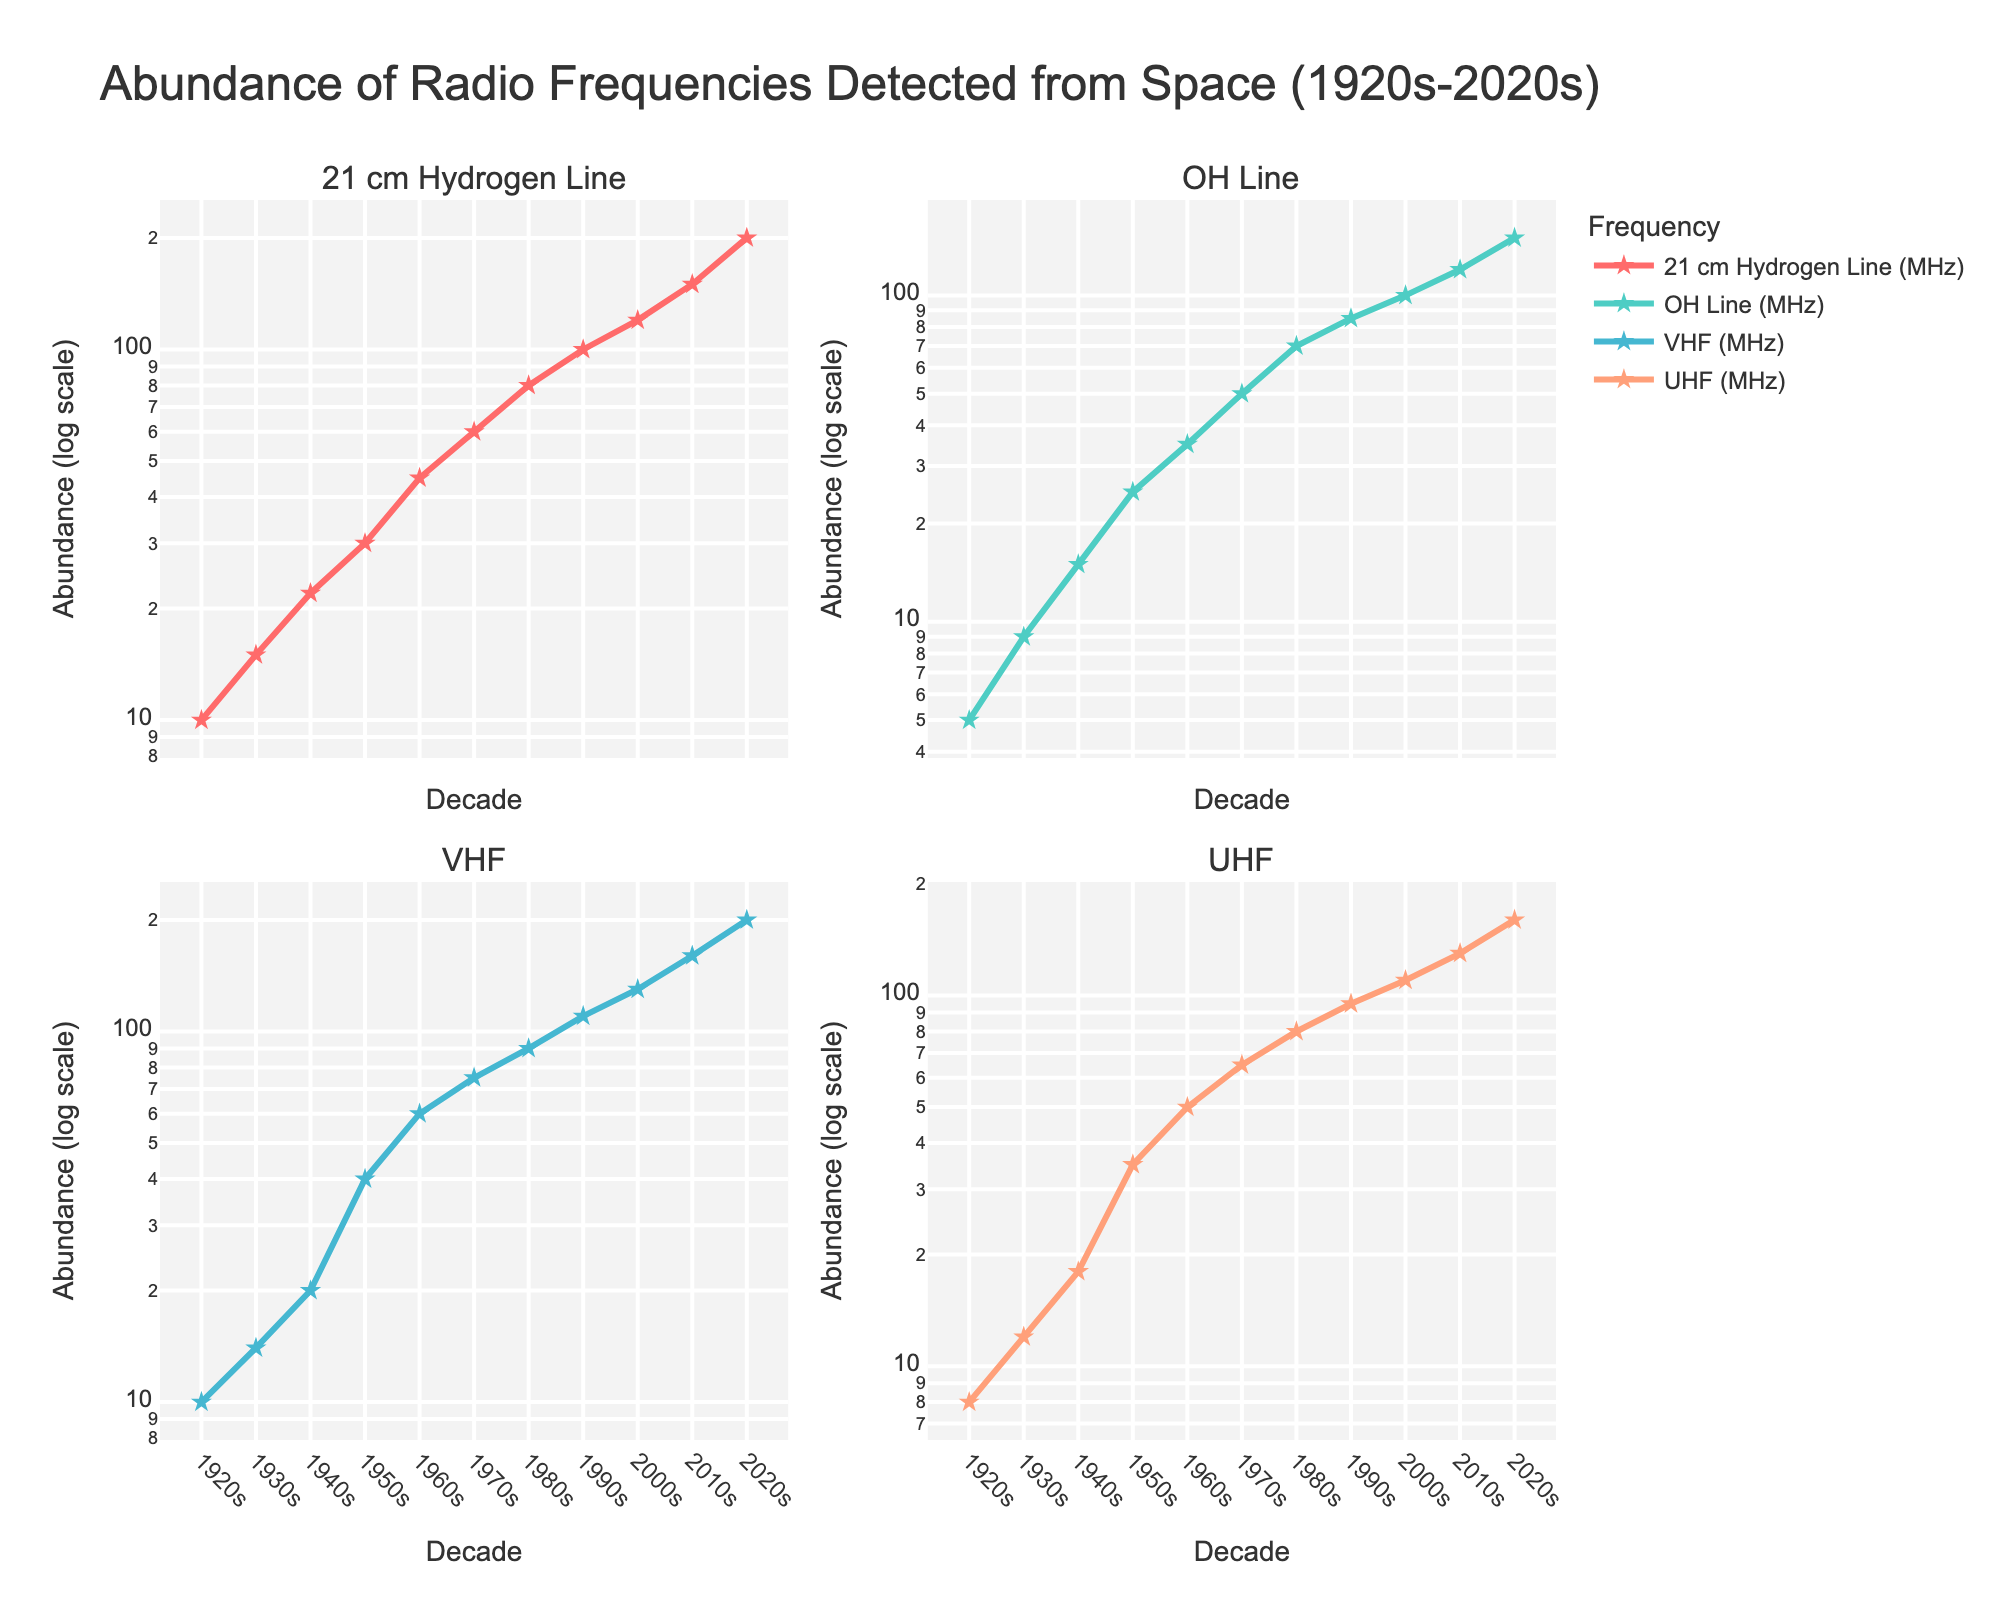What is the title of the plot? The title is found at the top of the plot and provides an overview of the data depicted. In this case, it reads: "Abundance of Radio Frequencies Detected from Space (1920s-2020s)"
Answer: Abundance of Radio Frequencies Detected from Space (1920s-2020s) What are the four frequencies analyzed in the subplots? By looking at the subplot titles, we can identify the four frequencies. They are "21 cm Hydrogen Line," "OH Line," "VHF," and "UHF."
Answer: 21 cm Hydrogen Line, OH Line, VHF, UHF Which decade shows the highest abundance for the OH Line frequency? We identify the OH Line subplot and observe that the highest value is in the 2020s.
Answer: 2020s How did the abundance of the 21 cm Hydrogen Line change from the 1930s to the 1940s? By comparing the data points in the 21 cm Hydrogen Line subplot for the 1930s and 1940s, we see an increase from 15 to 22.
Answer: Increased from 15 to 22 Compare the increase in abundance of VHF from the 1950s to the 1960s with that of UHF for the same period. Which increased more? For VHF, the abundance increases from 40 to 60 (20 units). For UHF, it increases from 35 to 50 (15 units). So, VHF increased more.
Answer: VHF What can you infer about the trend in the abundance of detected frequencies over the century? By examining all subplots, we notice an overall upward trend across all frequencies, indicating an increase in detected frequencies over the decades.
Answer: Upward trend In the 1970s, which frequency had the closest abundance to 50? By comparing the data points for each frequency in the 1970s, we see UHF had an abundance of 65, which is the closest to 50.
Answer: UHF On a log scale, how significant is the increase in the abundance of the 21 cm Hydrogen Line from the 1920s to the 2020s? On a log scale, the increase from 10 in the 1920s to 200 in the 2020s represents a 20-fold increase. By multiplying sequentially (10 to 200), the increments are multiplicative, which log scales effectively display.
Answer: 20-fold Which frequency showed the least increase in abundance from the 1920s to the 2020s? By comparing the values, the OH Line increased from 5 to 150, whereas the others increased more.
Answer: OH Line What is the average abundance of the VHF frequency over the last century? Sum up the VHF values across the decades (10+14+20+40+60+75+90+110+130+160+200 = 909) and divide by the number of data points (11). This gives an average of 82.64.
Answer: 82.64 